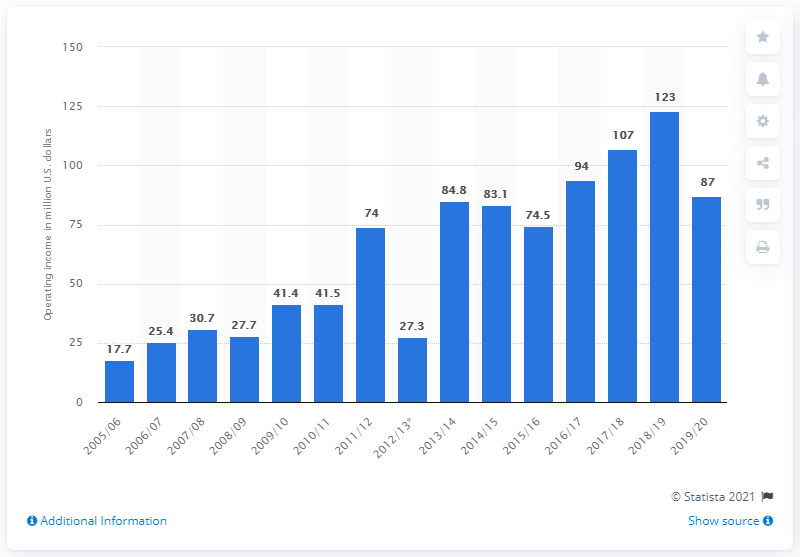Outline some significant characteristics in this image. The operating income of the New York Rangers in the 2019/20 season was $87 million. 